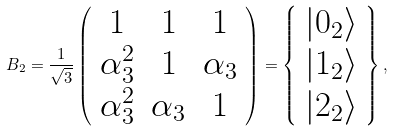Convert formula to latex. <formula><loc_0><loc_0><loc_500><loc_500>B _ { 2 } = \frac { 1 } { \sqrt { 3 } } \left ( \begin{array} { c c c } 1 & 1 & 1 \\ \alpha _ { 3 } ^ { 2 } & 1 & \alpha _ { 3 } \\ \alpha _ { 3 } ^ { 2 } & \alpha _ { 3 } & 1 \end{array} \right ) = \left \{ \begin{array} { l } | 0 _ { 2 } \rangle \\ | 1 _ { 2 } \rangle \\ | 2 _ { 2 } \rangle \end{array} \right \} ,</formula> 